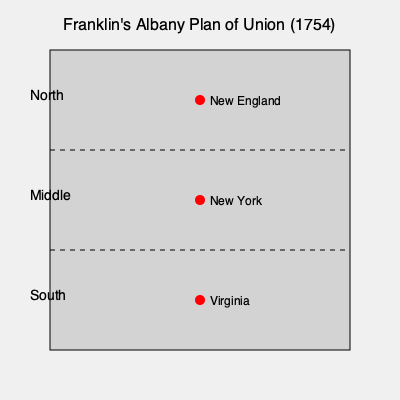Based on the map of Franklin's Albany Plan of Union, how many major regions did the proposed union divide the colonies into? 1. Examine the map carefully, noting its title "Franklin's Albany Plan of Union (1754)".

2. Observe the vertical layout of the map, which shows distinct divisions.

3. Count the number of labeled sections:
   - The top section is labeled "North"
   - The middle section is labeled "Middle"
   - The bottom section is labeled "South"

4. Note that each section contains a representative colony:
   - North: New England
   - Middle: New York
   - South: Virginia

5. Conclude that the map divides the colonies into three major regions: North, Middle, and South.

This division reflects Franklin's proposal to unite the colonies under a centralized government while maintaining regional distinctions, an early attempt at balancing local and federal power in what would later become the United States.
Answer: Three regions 